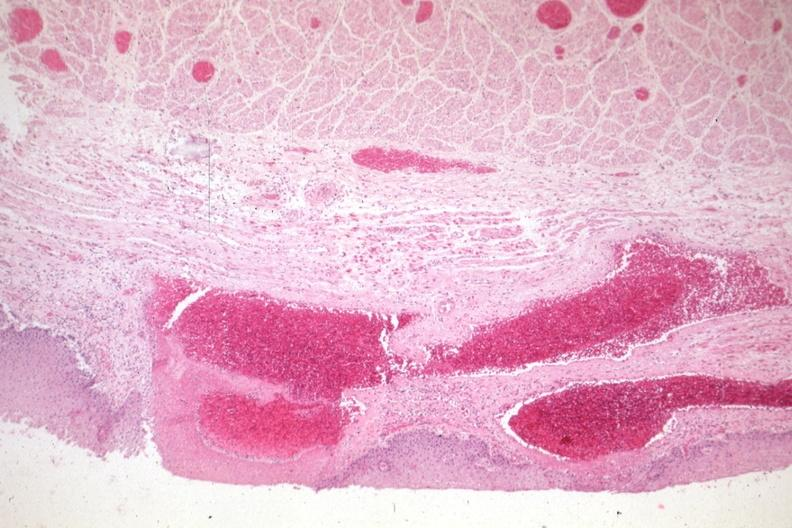does cardiovascular show good example of varices?
Answer the question using a single word or phrase. No 